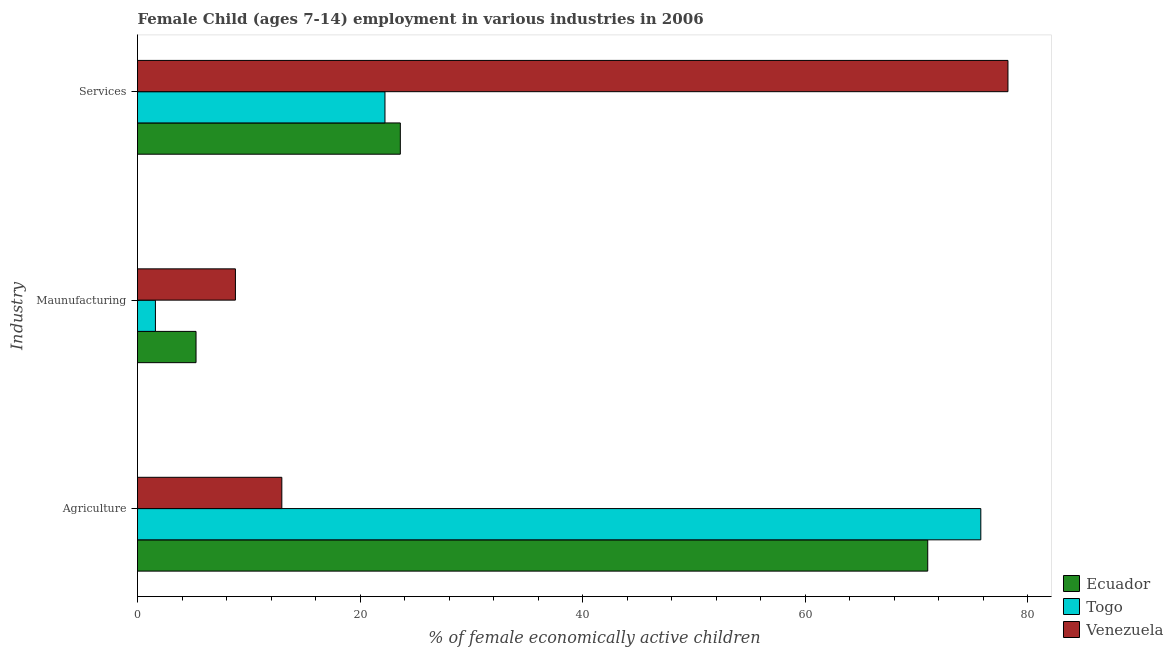Are the number of bars per tick equal to the number of legend labels?
Offer a terse response. Yes. How many bars are there on the 3rd tick from the bottom?
Make the answer very short. 3. What is the label of the 1st group of bars from the top?
Your response must be concise. Services. What is the percentage of economically active children in manufacturing in Ecuador?
Make the answer very short. 5.26. Across all countries, what is the maximum percentage of economically active children in agriculture?
Keep it short and to the point. 75.79. Across all countries, what is the minimum percentage of economically active children in manufacturing?
Your response must be concise. 1.61. In which country was the percentage of economically active children in services maximum?
Offer a very short reply. Venezuela. In which country was the percentage of economically active children in agriculture minimum?
Your answer should be very brief. Venezuela. What is the total percentage of economically active children in manufacturing in the graph?
Your response must be concise. 15.67. What is the difference between the percentage of economically active children in manufacturing in Venezuela and that in Ecuador?
Keep it short and to the point. 3.54. What is the difference between the percentage of economically active children in manufacturing in Venezuela and the percentage of economically active children in agriculture in Togo?
Your answer should be very brief. -66.99. What is the average percentage of economically active children in agriculture per country?
Your answer should be compact. 53.26. What is the difference between the percentage of economically active children in services and percentage of economically active children in agriculture in Togo?
Make the answer very short. -53.55. In how many countries, is the percentage of economically active children in services greater than 76 %?
Make the answer very short. 1. What is the ratio of the percentage of economically active children in services in Venezuela to that in Ecuador?
Ensure brevity in your answer.  3.31. Is the percentage of economically active children in services in Ecuador less than that in Venezuela?
Give a very brief answer. Yes. What is the difference between the highest and the second highest percentage of economically active children in manufacturing?
Offer a very short reply. 3.54. What is the difference between the highest and the lowest percentage of economically active children in services?
Provide a short and direct response. 55.99. What does the 2nd bar from the top in Maunufacturing represents?
Make the answer very short. Togo. What does the 2nd bar from the bottom in Maunufacturing represents?
Provide a short and direct response. Togo. Are all the bars in the graph horizontal?
Offer a terse response. Yes. How many countries are there in the graph?
Offer a terse response. 3. What is the difference between two consecutive major ticks on the X-axis?
Offer a terse response. 20. Are the values on the major ticks of X-axis written in scientific E-notation?
Your answer should be very brief. No. Does the graph contain any zero values?
Offer a very short reply. No. Does the graph contain grids?
Make the answer very short. No. How many legend labels are there?
Make the answer very short. 3. What is the title of the graph?
Keep it short and to the point. Female Child (ages 7-14) employment in various industries in 2006. What is the label or title of the X-axis?
Provide a short and direct response. % of female economically active children. What is the label or title of the Y-axis?
Offer a very short reply. Industry. What is the % of female economically active children of Ecuador in Agriculture?
Ensure brevity in your answer.  71.02. What is the % of female economically active children in Togo in Agriculture?
Keep it short and to the point. 75.79. What is the % of female economically active children in Venezuela in Agriculture?
Give a very brief answer. 12.97. What is the % of female economically active children of Ecuador in Maunufacturing?
Offer a very short reply. 5.26. What is the % of female economically active children in Togo in Maunufacturing?
Ensure brevity in your answer.  1.61. What is the % of female economically active children in Ecuador in Services?
Offer a terse response. 23.62. What is the % of female economically active children of Togo in Services?
Offer a terse response. 22.24. What is the % of female economically active children of Venezuela in Services?
Your answer should be very brief. 78.23. Across all Industry, what is the maximum % of female economically active children in Ecuador?
Your response must be concise. 71.02. Across all Industry, what is the maximum % of female economically active children in Togo?
Your response must be concise. 75.79. Across all Industry, what is the maximum % of female economically active children in Venezuela?
Provide a succinct answer. 78.23. Across all Industry, what is the minimum % of female economically active children in Ecuador?
Give a very brief answer. 5.26. Across all Industry, what is the minimum % of female economically active children in Togo?
Your response must be concise. 1.61. What is the total % of female economically active children of Ecuador in the graph?
Provide a succinct answer. 99.9. What is the total % of female economically active children in Togo in the graph?
Provide a succinct answer. 99.64. What is the total % of female economically active children of Venezuela in the graph?
Make the answer very short. 100. What is the difference between the % of female economically active children of Ecuador in Agriculture and that in Maunufacturing?
Offer a terse response. 65.76. What is the difference between the % of female economically active children in Togo in Agriculture and that in Maunufacturing?
Your answer should be compact. 74.18. What is the difference between the % of female economically active children of Venezuela in Agriculture and that in Maunufacturing?
Ensure brevity in your answer.  4.17. What is the difference between the % of female economically active children of Ecuador in Agriculture and that in Services?
Your answer should be very brief. 47.4. What is the difference between the % of female economically active children of Togo in Agriculture and that in Services?
Offer a terse response. 53.55. What is the difference between the % of female economically active children in Venezuela in Agriculture and that in Services?
Your answer should be compact. -65.26. What is the difference between the % of female economically active children in Ecuador in Maunufacturing and that in Services?
Your response must be concise. -18.36. What is the difference between the % of female economically active children of Togo in Maunufacturing and that in Services?
Your response must be concise. -20.63. What is the difference between the % of female economically active children of Venezuela in Maunufacturing and that in Services?
Provide a short and direct response. -69.43. What is the difference between the % of female economically active children of Ecuador in Agriculture and the % of female economically active children of Togo in Maunufacturing?
Keep it short and to the point. 69.41. What is the difference between the % of female economically active children of Ecuador in Agriculture and the % of female economically active children of Venezuela in Maunufacturing?
Offer a very short reply. 62.22. What is the difference between the % of female economically active children in Togo in Agriculture and the % of female economically active children in Venezuela in Maunufacturing?
Offer a terse response. 66.99. What is the difference between the % of female economically active children of Ecuador in Agriculture and the % of female economically active children of Togo in Services?
Give a very brief answer. 48.78. What is the difference between the % of female economically active children of Ecuador in Agriculture and the % of female economically active children of Venezuela in Services?
Make the answer very short. -7.21. What is the difference between the % of female economically active children of Togo in Agriculture and the % of female economically active children of Venezuela in Services?
Ensure brevity in your answer.  -2.44. What is the difference between the % of female economically active children of Ecuador in Maunufacturing and the % of female economically active children of Togo in Services?
Ensure brevity in your answer.  -16.98. What is the difference between the % of female economically active children in Ecuador in Maunufacturing and the % of female economically active children in Venezuela in Services?
Your answer should be very brief. -72.97. What is the difference between the % of female economically active children in Togo in Maunufacturing and the % of female economically active children in Venezuela in Services?
Provide a succinct answer. -76.62. What is the average % of female economically active children of Ecuador per Industry?
Keep it short and to the point. 33.3. What is the average % of female economically active children in Togo per Industry?
Keep it short and to the point. 33.21. What is the average % of female economically active children in Venezuela per Industry?
Provide a short and direct response. 33.33. What is the difference between the % of female economically active children in Ecuador and % of female economically active children in Togo in Agriculture?
Keep it short and to the point. -4.77. What is the difference between the % of female economically active children in Ecuador and % of female economically active children in Venezuela in Agriculture?
Keep it short and to the point. 58.05. What is the difference between the % of female economically active children of Togo and % of female economically active children of Venezuela in Agriculture?
Provide a succinct answer. 62.82. What is the difference between the % of female economically active children in Ecuador and % of female economically active children in Togo in Maunufacturing?
Your answer should be very brief. 3.65. What is the difference between the % of female economically active children of Ecuador and % of female economically active children of Venezuela in Maunufacturing?
Ensure brevity in your answer.  -3.54. What is the difference between the % of female economically active children in Togo and % of female economically active children in Venezuela in Maunufacturing?
Your response must be concise. -7.19. What is the difference between the % of female economically active children of Ecuador and % of female economically active children of Togo in Services?
Keep it short and to the point. 1.38. What is the difference between the % of female economically active children of Ecuador and % of female economically active children of Venezuela in Services?
Your response must be concise. -54.61. What is the difference between the % of female economically active children in Togo and % of female economically active children in Venezuela in Services?
Your answer should be compact. -55.99. What is the ratio of the % of female economically active children in Ecuador in Agriculture to that in Maunufacturing?
Your answer should be very brief. 13.5. What is the ratio of the % of female economically active children in Togo in Agriculture to that in Maunufacturing?
Make the answer very short. 47.07. What is the ratio of the % of female economically active children in Venezuela in Agriculture to that in Maunufacturing?
Your response must be concise. 1.47. What is the ratio of the % of female economically active children of Ecuador in Agriculture to that in Services?
Keep it short and to the point. 3.01. What is the ratio of the % of female economically active children in Togo in Agriculture to that in Services?
Make the answer very short. 3.41. What is the ratio of the % of female economically active children of Venezuela in Agriculture to that in Services?
Offer a terse response. 0.17. What is the ratio of the % of female economically active children of Ecuador in Maunufacturing to that in Services?
Your response must be concise. 0.22. What is the ratio of the % of female economically active children of Togo in Maunufacturing to that in Services?
Your answer should be compact. 0.07. What is the ratio of the % of female economically active children in Venezuela in Maunufacturing to that in Services?
Your answer should be very brief. 0.11. What is the difference between the highest and the second highest % of female economically active children of Ecuador?
Your answer should be compact. 47.4. What is the difference between the highest and the second highest % of female economically active children in Togo?
Keep it short and to the point. 53.55. What is the difference between the highest and the second highest % of female economically active children in Venezuela?
Provide a succinct answer. 65.26. What is the difference between the highest and the lowest % of female economically active children of Ecuador?
Offer a terse response. 65.76. What is the difference between the highest and the lowest % of female economically active children of Togo?
Your response must be concise. 74.18. What is the difference between the highest and the lowest % of female economically active children of Venezuela?
Ensure brevity in your answer.  69.43. 